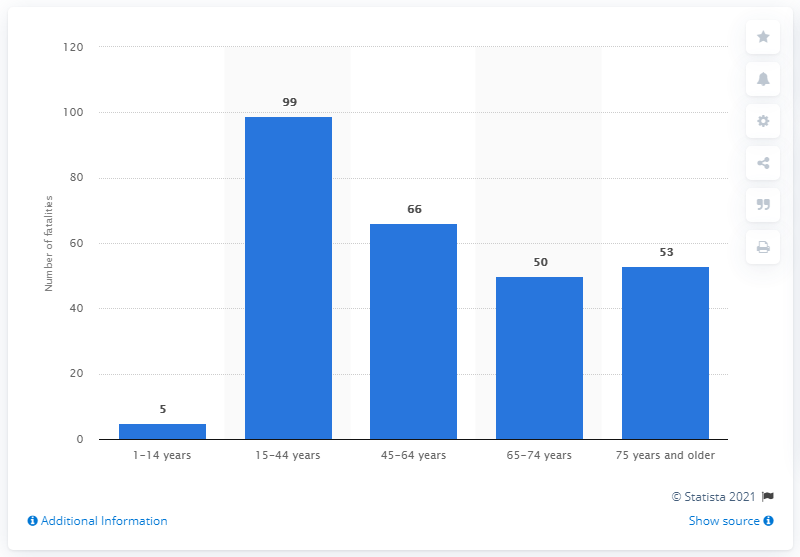List a handful of essential elements in this visual. There were 99 deaths in traffic accidents between the ages of 15 and 44 in Sweden in 2019. In 2019, a total of 53 deaths were registered among Swedes in the oldest age group. 